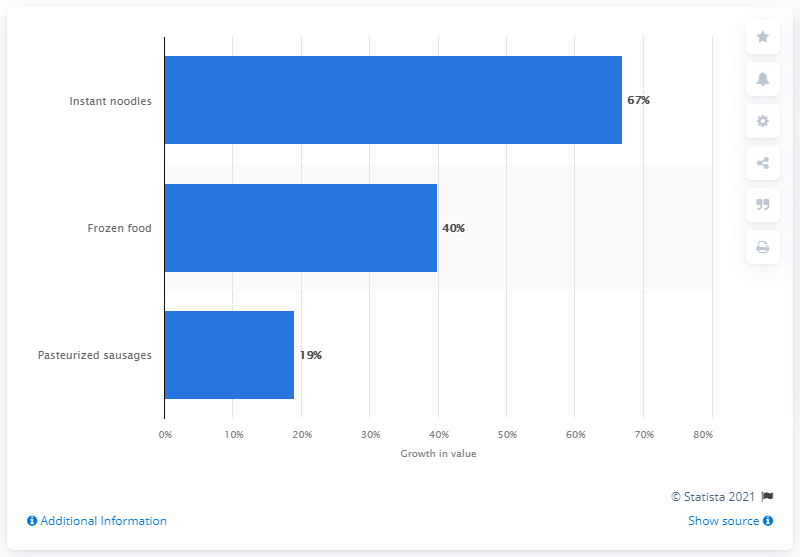Draw attention to some important aspects in this diagram. The value growth of instant noodles after the COVID-19 outbreak was 67%. 